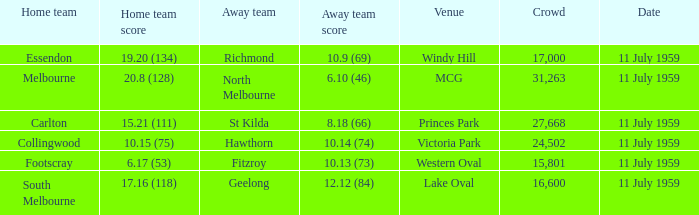Could you parse the entire table as a dict? {'header': ['Home team', 'Home team score', 'Away team', 'Away team score', 'Venue', 'Crowd', 'Date'], 'rows': [['Essendon', '19.20 (134)', 'Richmond', '10.9 (69)', 'Windy Hill', '17,000', '11 July 1959'], ['Melbourne', '20.8 (128)', 'North Melbourne', '6.10 (46)', 'MCG', '31,263', '11 July 1959'], ['Carlton', '15.21 (111)', 'St Kilda', '8.18 (66)', 'Princes Park', '27,668', '11 July 1959'], ['Collingwood', '10.15 (75)', 'Hawthorn', '10.14 (74)', 'Victoria Park', '24,502', '11 July 1959'], ['Footscray', '6.17 (53)', 'Fitzroy', '10.13 (73)', 'Western Oval', '15,801', '11 July 1959'], ['South Melbourne', '17.16 (118)', 'Geelong', '12.12 (84)', 'Lake Oval', '16,600', '11 July 1959']]} What is the home team's score when richmond is away? 19.20 (134). 